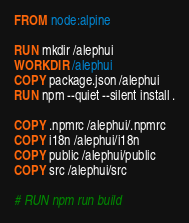Convert code to text. <code><loc_0><loc_0><loc_500><loc_500><_Dockerfile_>FROM node:alpine

RUN mkdir /alephui
WORKDIR /alephui
COPY package.json /alephui
RUN npm --quiet --silent install .

COPY .npmrc /alephui/.npmrc
COPY i18n /alephui/i18n
COPY public /alephui/public
COPY src /alephui/src

# RUN npm run build
</code> 